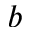<formula> <loc_0><loc_0><loc_500><loc_500>b</formula> 